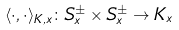<formula> <loc_0><loc_0><loc_500><loc_500>\langle \cdot , \cdot \rangle _ { K , x } \colon S ^ { \pm } _ { x } \times S ^ { \pm } _ { x } \to K _ { x }</formula> 